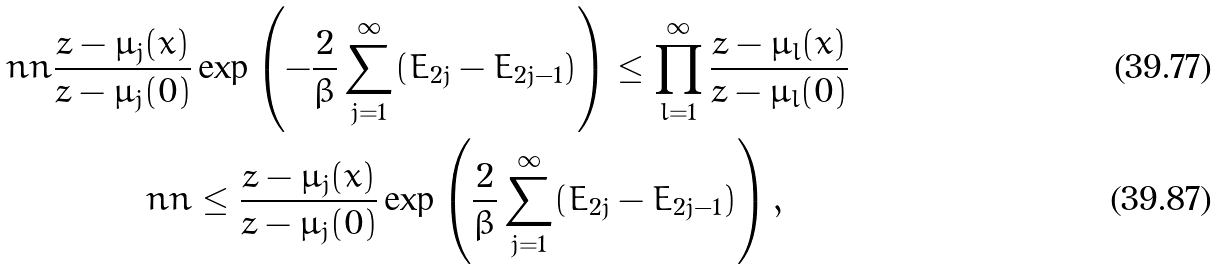Convert formula to latex. <formula><loc_0><loc_0><loc_500><loc_500>\ n n \frac { z - \mu _ { j } ( x ) } { z - \mu _ { j } ( 0 ) } & \exp \left ( - \frac { 2 } { \beta } \sum _ { j = 1 } ^ { \infty } ( E _ { 2 j } - E _ { 2 j - 1 } ) \right ) \leq \prod _ { l = 1 } ^ { \infty } \frac { z - \mu _ { l } ( x ) } { z - \mu _ { l } ( 0 ) } \\ \ n n & \leq \frac { z - \mu _ { j } ( x ) } { z - \mu _ { j } ( 0 ) } \exp \left ( \frac { 2 } { \beta } \sum _ { j = 1 } ^ { \infty } ( E _ { 2 j } - { E _ { 2 j - 1 } } ) \right ) ,</formula> 